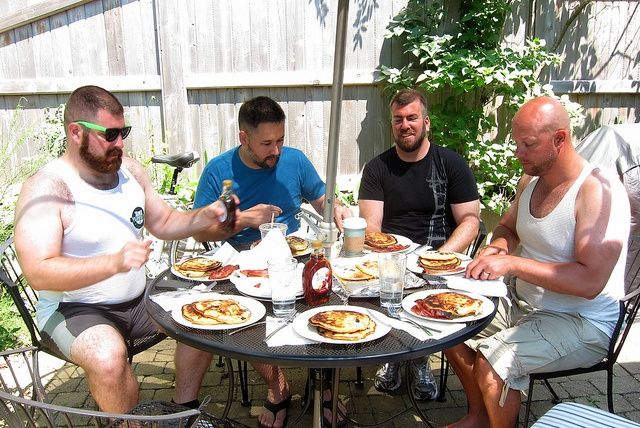Describe the objects in this image and their specific colors. I can see dining table in lightgray, white, black, gray, and darkgray tones, people in lightgray, white, brown, lightpink, and gray tones, people in lightgray, white, darkgray, brown, and gray tones, people in lightgray, black, salmon, brown, and gray tones, and people in lightgray, teal, navy, black, and brown tones in this image. 